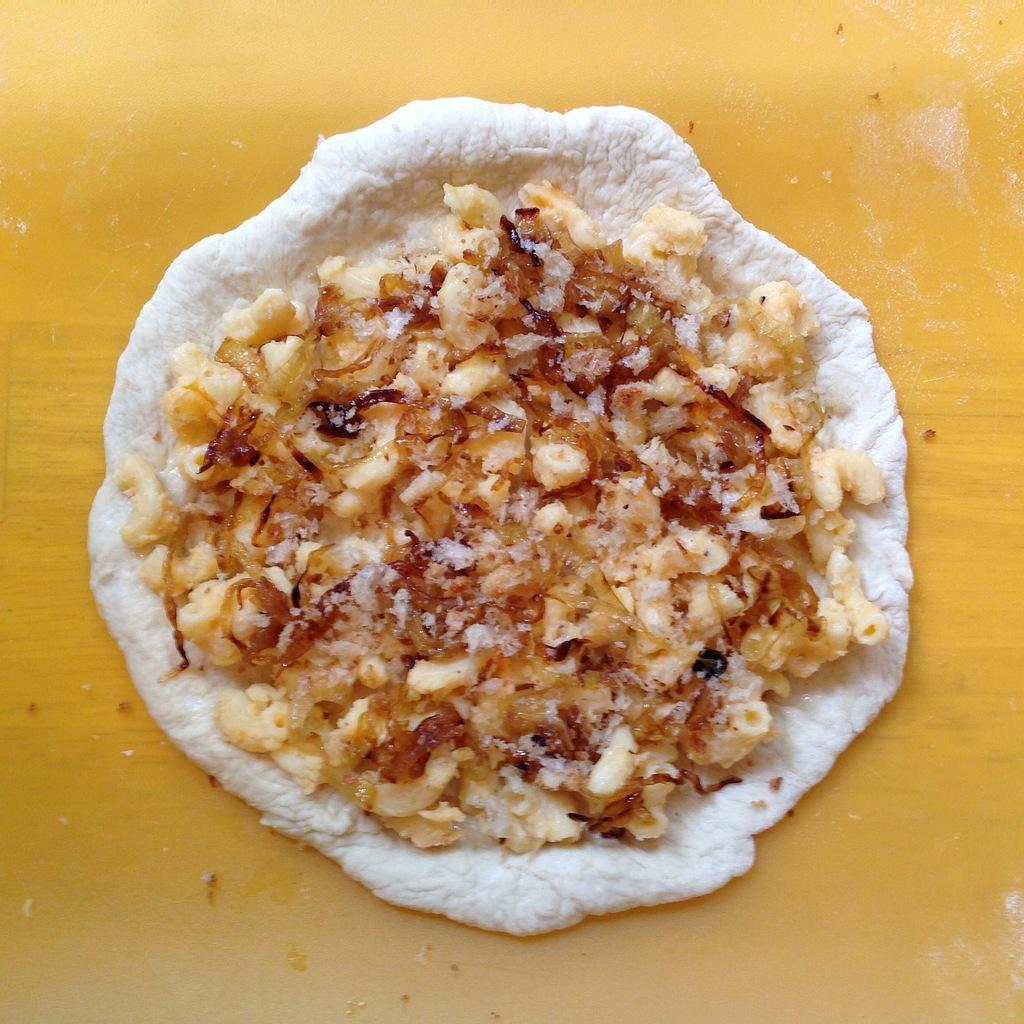What is the main subject of the image? The main subject of the image is food. What can be observed about the table in the image? The food is placed on a yellow table. What colors are the food items in the image? The food is in white and yellow colors. Can you tell me how many drinks are present on the yellow table in the image? There is no drink present in the image; it only features food. What type of death can be seen in the image? There is no death present in the image; it only features food on a yellow table. 